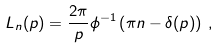<formula> <loc_0><loc_0><loc_500><loc_500>L _ { n } ( p ) = \frac { 2 \pi } { p } \phi ^ { - 1 } \left ( \pi n - \delta ( p ) \right ) \, ,</formula> 